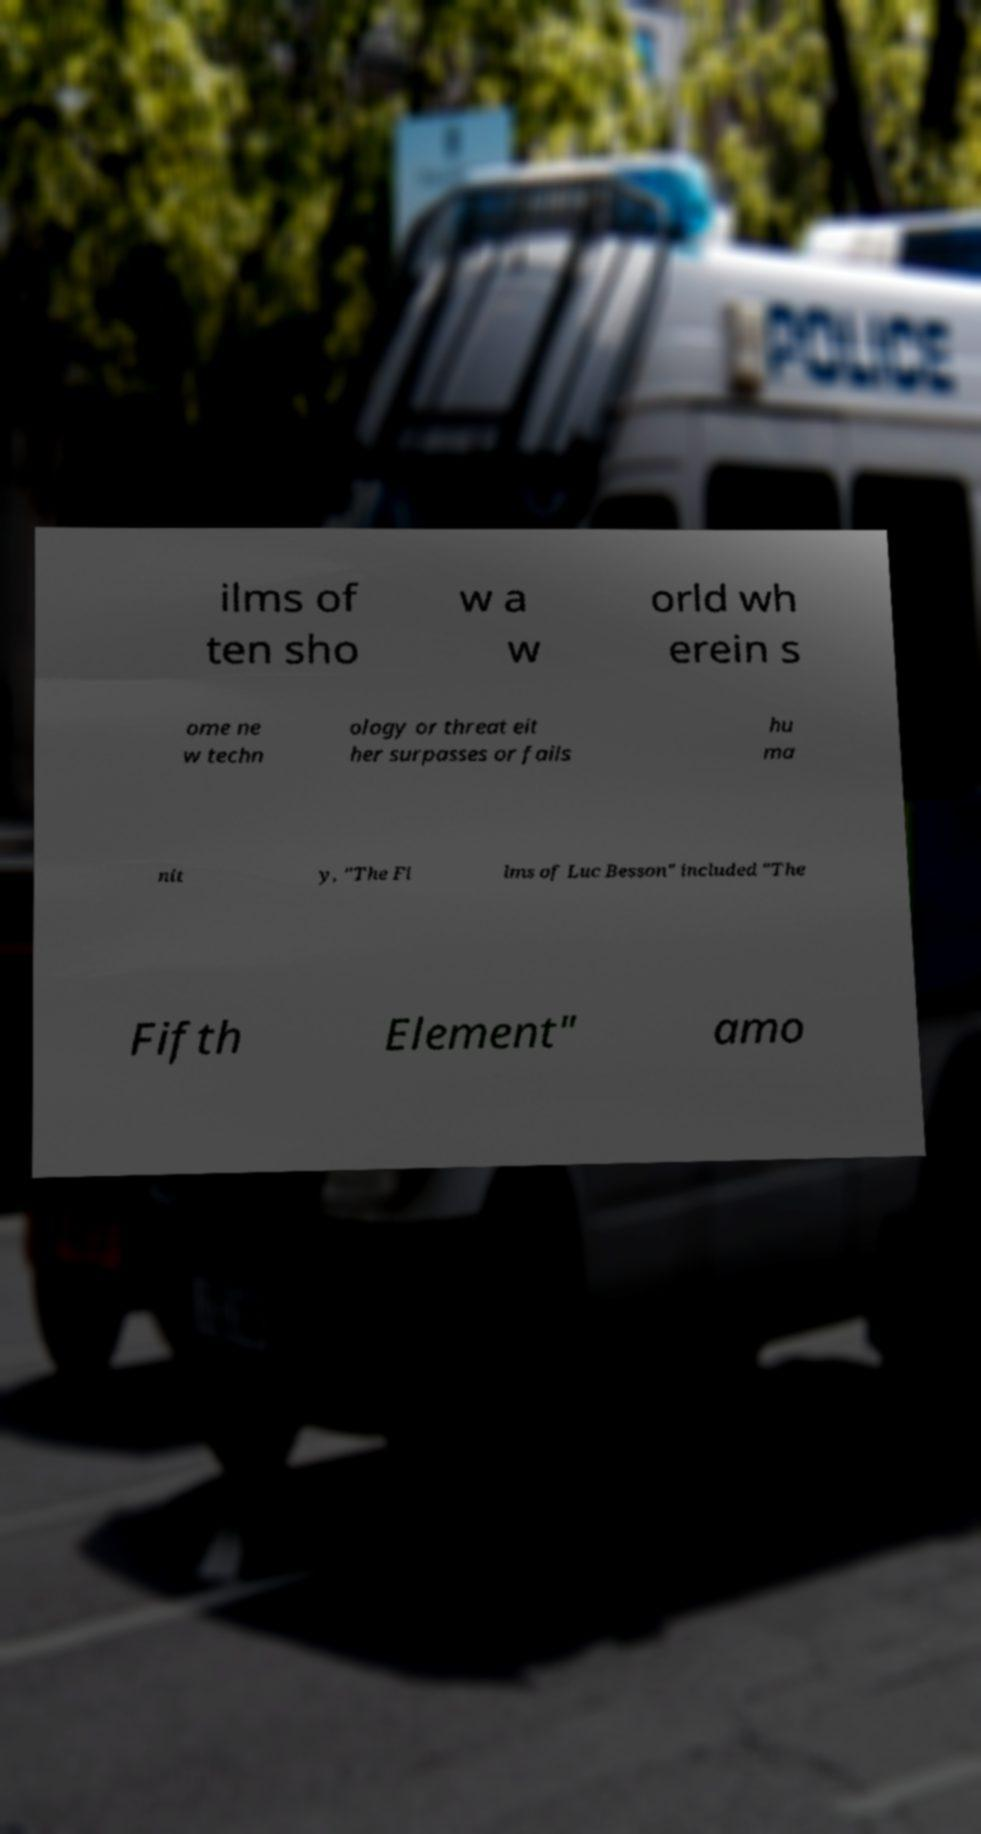Could you extract and type out the text from this image? ilms of ten sho w a w orld wh erein s ome ne w techn ology or threat eit her surpasses or fails hu ma nit y, "The Fi lms of Luc Besson" included "The Fifth Element" amo 